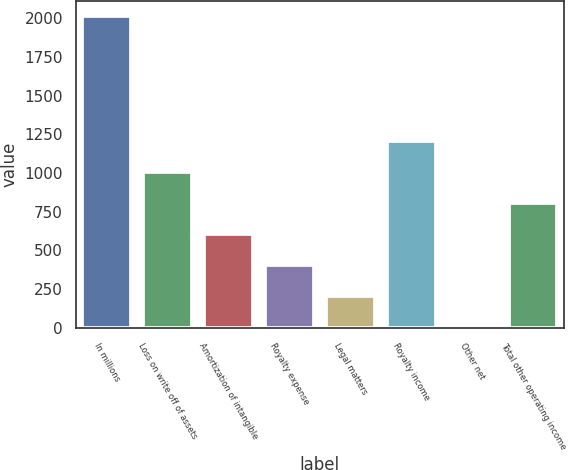Convert chart to OTSL. <chart><loc_0><loc_0><loc_500><loc_500><bar_chart><fcel>In millions<fcel>Loss on write off of assets<fcel>Amortization of intangible<fcel>Royalty expense<fcel>Legal matters<fcel>Royalty income<fcel>Other net<fcel>Total other operating income<nl><fcel>2014<fcel>1008<fcel>605.6<fcel>404.4<fcel>203.2<fcel>1209.2<fcel>2<fcel>806.8<nl></chart> 